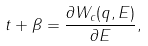<formula> <loc_0><loc_0><loc_500><loc_500>t + \beta = \frac { \partial W _ { c } ( q , E ) } { \partial E } ,</formula> 